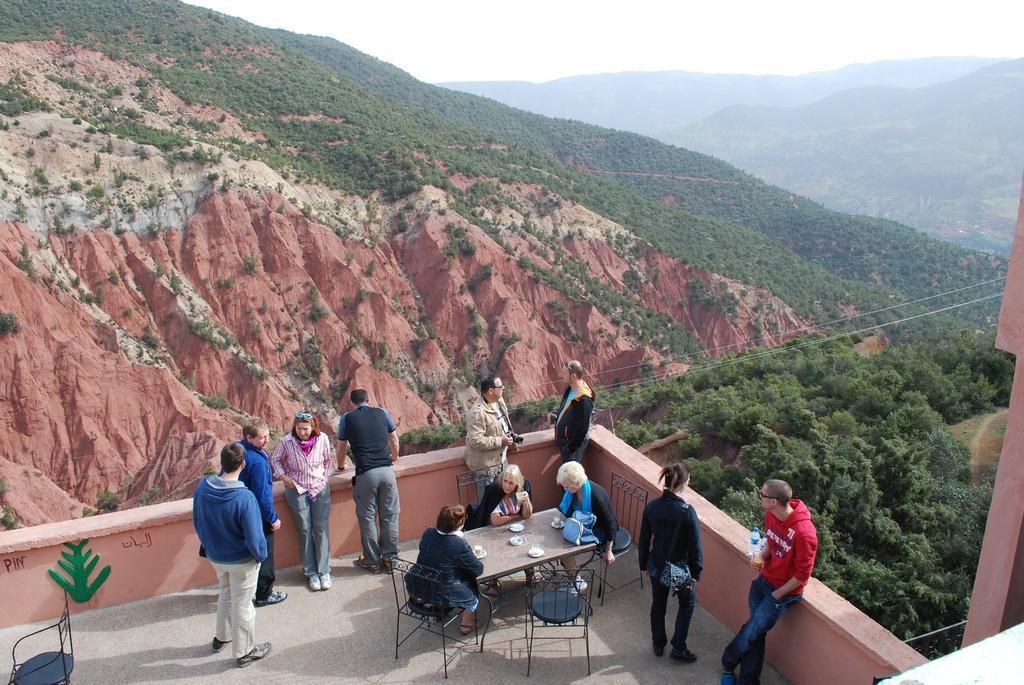Describe this image in one or two sentences. In this picture, we can see a few people on the floor, we can see some tables chairs, wall, and we can see some objects on the table, we can see the sky, mountains, trees, plants, wires. 